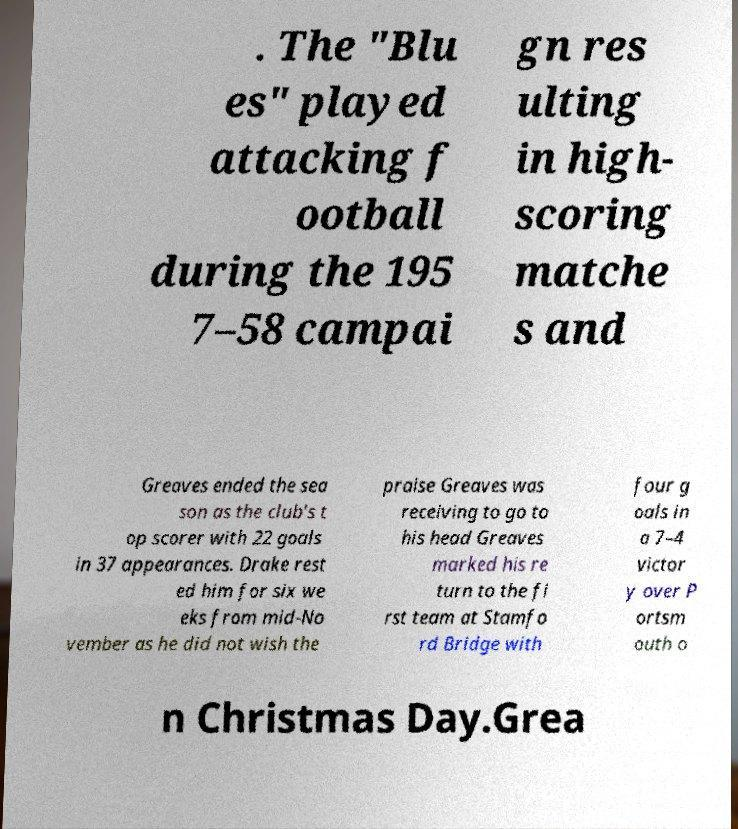There's text embedded in this image that I need extracted. Can you transcribe it verbatim? . The "Blu es" played attacking f ootball during the 195 7–58 campai gn res ulting in high- scoring matche s and Greaves ended the sea son as the club's t op scorer with 22 goals in 37 appearances. Drake rest ed him for six we eks from mid-No vember as he did not wish the praise Greaves was receiving to go to his head Greaves marked his re turn to the fi rst team at Stamfo rd Bridge with four g oals in a 7–4 victor y over P ortsm outh o n Christmas Day.Grea 